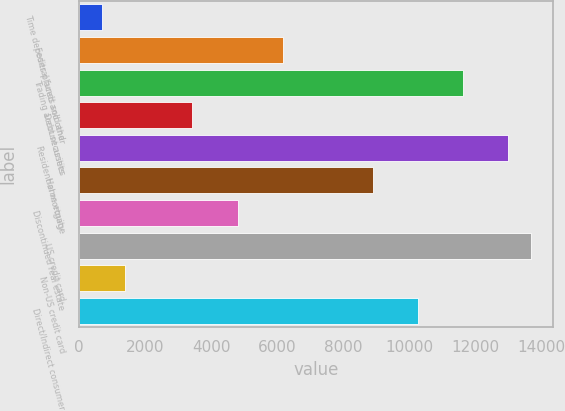Convert chart. <chart><loc_0><loc_0><loc_500><loc_500><bar_chart><fcel>Time deposits placed and other<fcel>Federal funds sold and<fcel>Trading account assets<fcel>Debt securities<fcel>Residential mortgage<fcel>Home equity<fcel>Discontinued real estate<fcel>US credit card<fcel>Non-US credit card<fcel>Direct/Indirect consumer<nl><fcel>698.5<fcel>6166.5<fcel>11634.5<fcel>3432.5<fcel>13001.5<fcel>8900.5<fcel>4799.5<fcel>13685<fcel>1382<fcel>10267.5<nl></chart> 